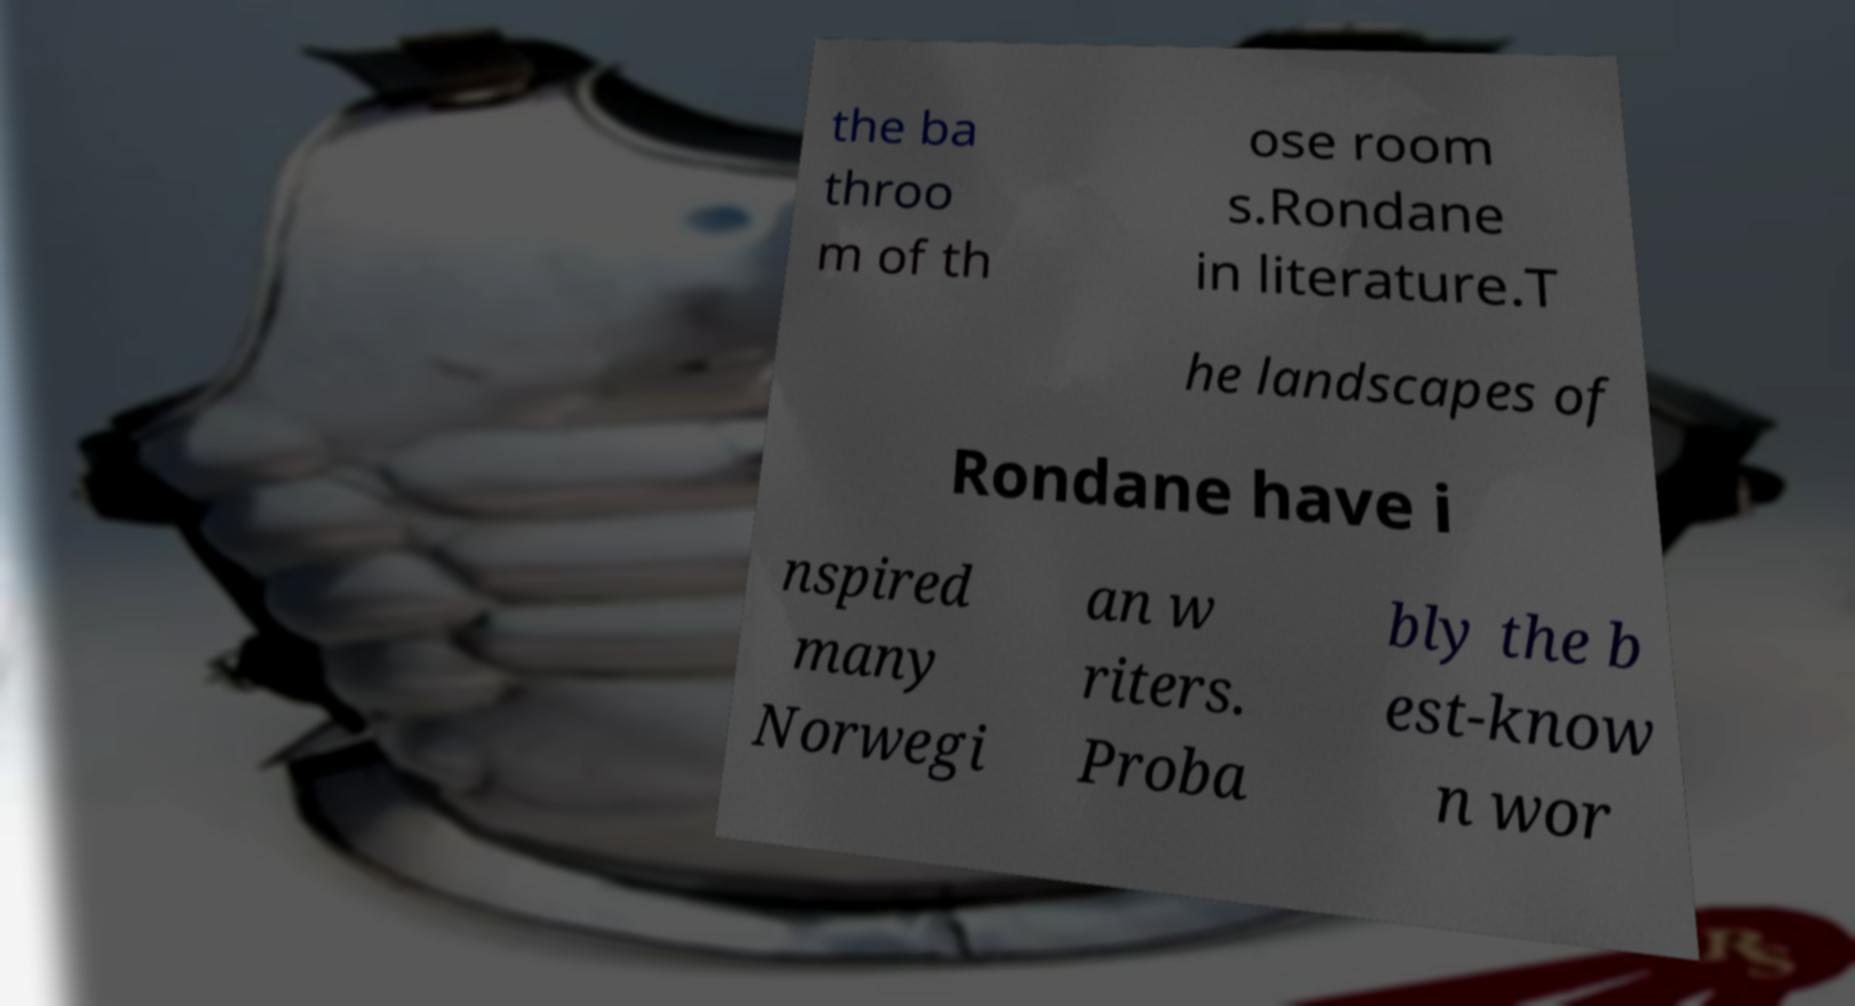There's text embedded in this image that I need extracted. Can you transcribe it verbatim? the ba throo m of th ose room s.Rondane in literature.T he landscapes of Rondane have i nspired many Norwegi an w riters. Proba bly the b est-know n wor 